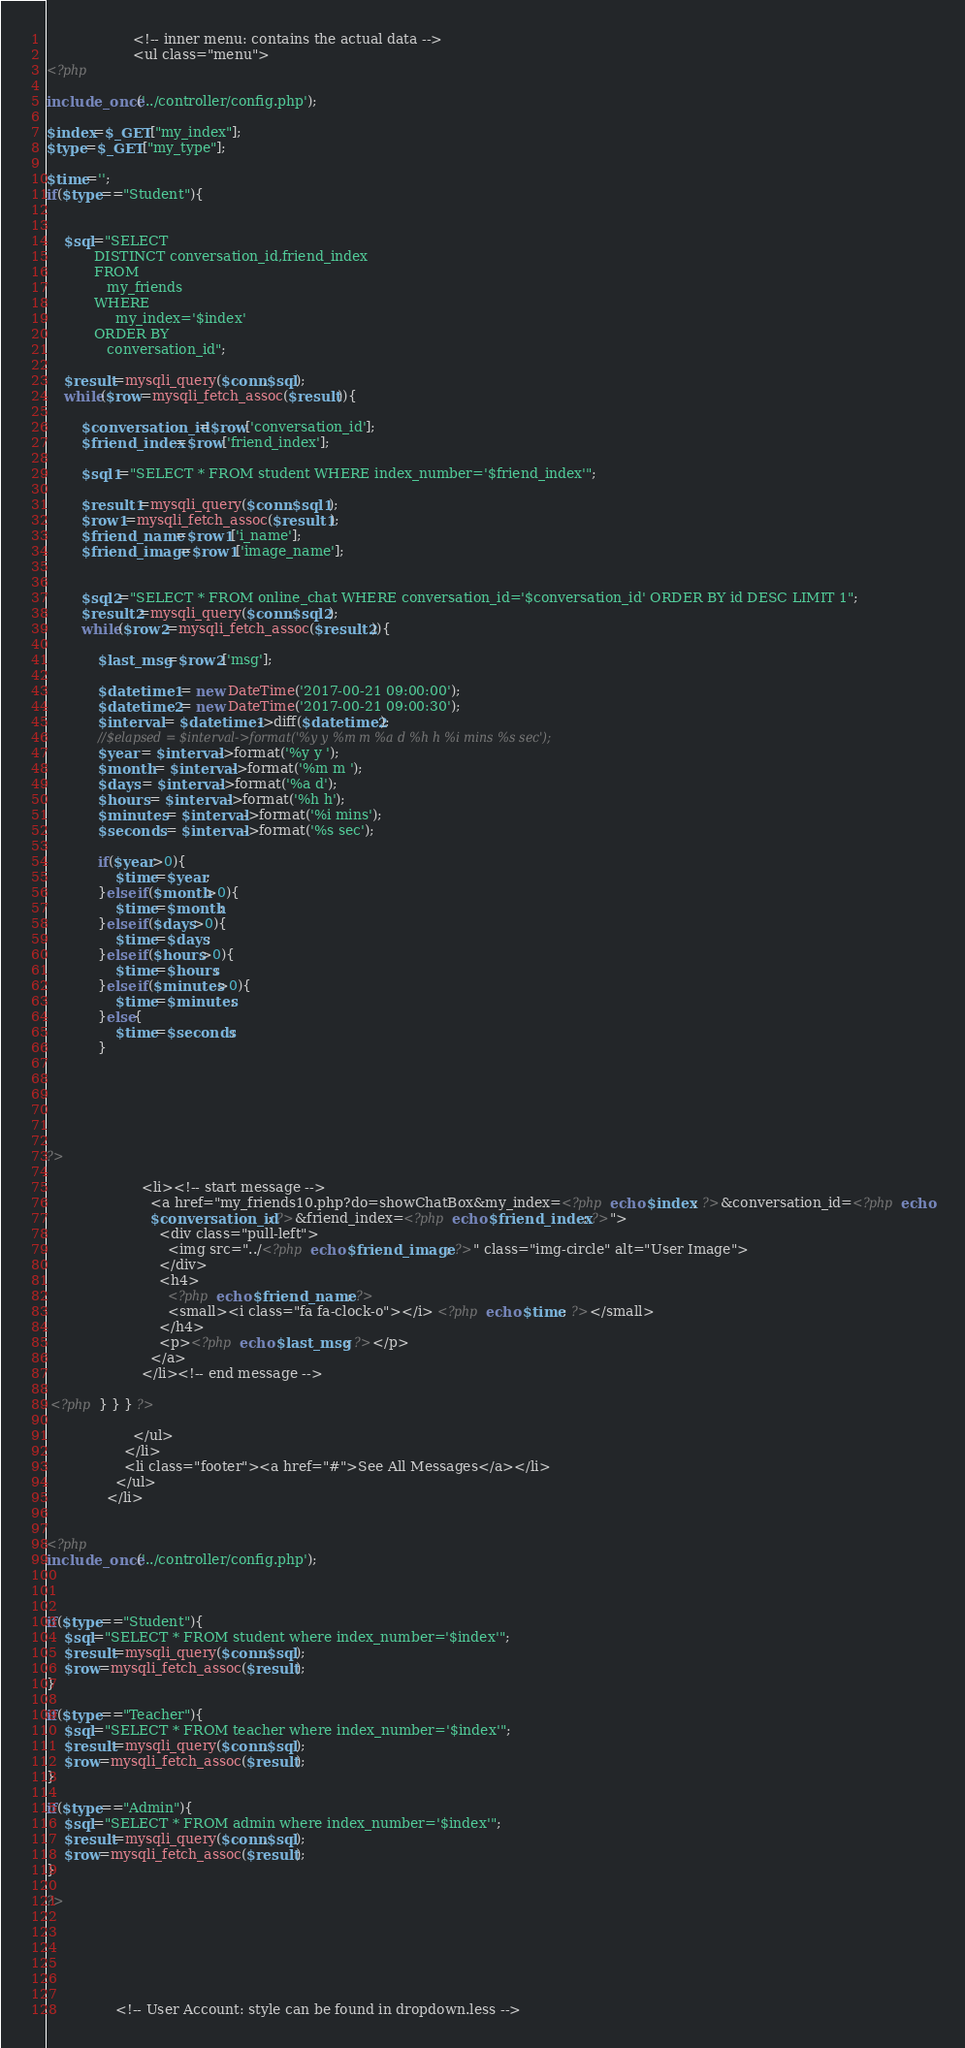<code> <loc_0><loc_0><loc_500><loc_500><_PHP_>                    <!-- inner menu: contains the actual data -->
                    <ul class="menu">
<?php

include_once('../controller/config.php');

$index=$_GET["my_index"];
$type=$_GET["my_type"];

$time='';
if($type=="Student"){
	
	
	$sql="SELECT 
           DISTINCT conversation_id,friend_index 
           FROM
              my_friends
           WHERE
              	my_index='$index'  
           ORDER BY
              conversation_id";
	
	$result=mysqli_query($conn,$sql);
	while($row=mysqli_fetch_assoc($result)){
		
		$conversation_id=$row['conversation_id'];
		$friend_index=$row['friend_index'];
		
		$sql1="SELECT * FROM student WHERE index_number='$friend_index'";	
		
		$result1=mysqli_query($conn,$sql1);
		$row1=mysqli_fetch_assoc($result1);
		$friend_name=$row1['i_name'];
		$friend_image=$row1['image_name'];
		
		
		$sql2="SELECT * FROM online_chat WHERE conversation_id='$conversation_id' ORDER BY id DESC LIMIT 1";	
		$result2=mysqli_query($conn,$sql2);
		while($row2=mysqli_fetch_assoc($result2)){
		
			$last_msg=$row2['msg'];
			
			$datetime1 = new DateTime('2017-00-21 09:00:00');
			$datetime2 = new DateTime('2017-00-21 09:00:30');
			$interval = $datetime1->diff($datetime2);
			//$elapsed = $interval->format('%y y %m m %a d %h h %i mins %s sec');			
			$year = $interval->format('%y y ');
			$month = $interval->format('%m m ');
			$days = $interval->format('%a d');
			$hours = $interval->format('%h h');
			$minutes = $interval->format('%i mins');
			$seconds = $interval->format('%s sec');
			
			if($year>0){
				$time=$year;
			}else if($month>0){
				$time=$month;
			}else if($days>0){
				$time=$days;
			}else if($hours>0){
				$time=$hours;
			}else if($minutes>0){
				$time=$minutes;
			}else{
				$time=$seconds;
			}
			
			
			
			
		

?>                      
                      
                      <li><!-- start message -->
                        <a href="my_friends10.php?do=showChatBox&my_index=<?php echo $index; ?>&conversation_id=<?php echo
						$conversation_id; ?>&friend_index=<?php echo $friend_index; ?>">
                          <div class="pull-left">
                            <img src="../<?php echo $friend_image; ?>" class="img-circle" alt="User Image">
                          </div>
                          <h4>
                            <?php echo $friend_name; ?>
                            <small><i class="fa fa-clock-o"></i> <?php echo $time; ?></small>
                          </h4>
                          <p><?php echo $last_msg; ?></p>
                        </a>
                      </li><!-- end message -->
                      
 <?php } } } ?>                     
                     
                    </ul>
                  </li>
                  <li class="footer"><a href="#">See All Messages</a></li>
                </ul>
              </li> 


<?php
include_once('../controller/config.php');



if($type=="Student"){
	$sql="SELECT * FROM student where index_number='$index'";
	$result=mysqli_query($conn,$sql);
	$row=mysqli_fetch_assoc($result);
}

if($type=="Teacher"){
	$sql="SELECT * FROM teacher where index_number='$index'";
	$result=mysqli_query($conn,$sql);
	$row=mysqli_fetch_assoc($result);	
}

if($type=="Admin"){
	$sql="SELECT * FROM admin where index_number='$index'";
	$result=mysqli_query($conn,$sql);
	$row=mysqli_fetch_assoc($result);	
}

?> 





                
                <!-- User Account: style can be found in dropdown.less --></code> 